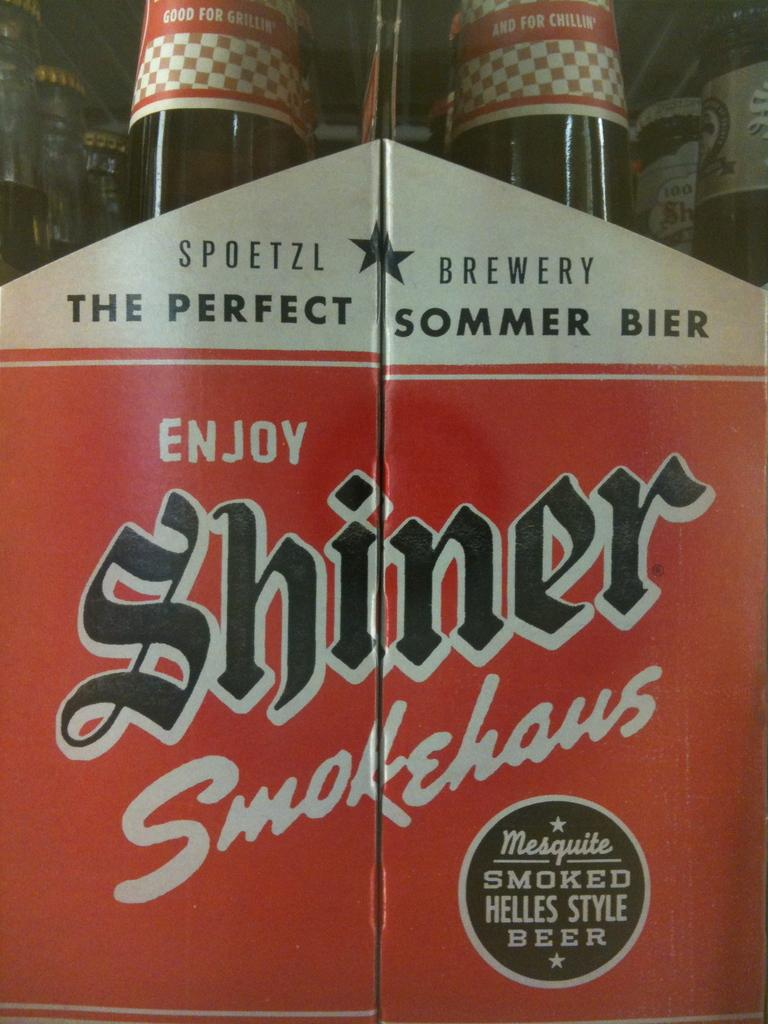<image>
Give a short and clear explanation of the subsequent image. the word Shiner is on the bottles of liquid 